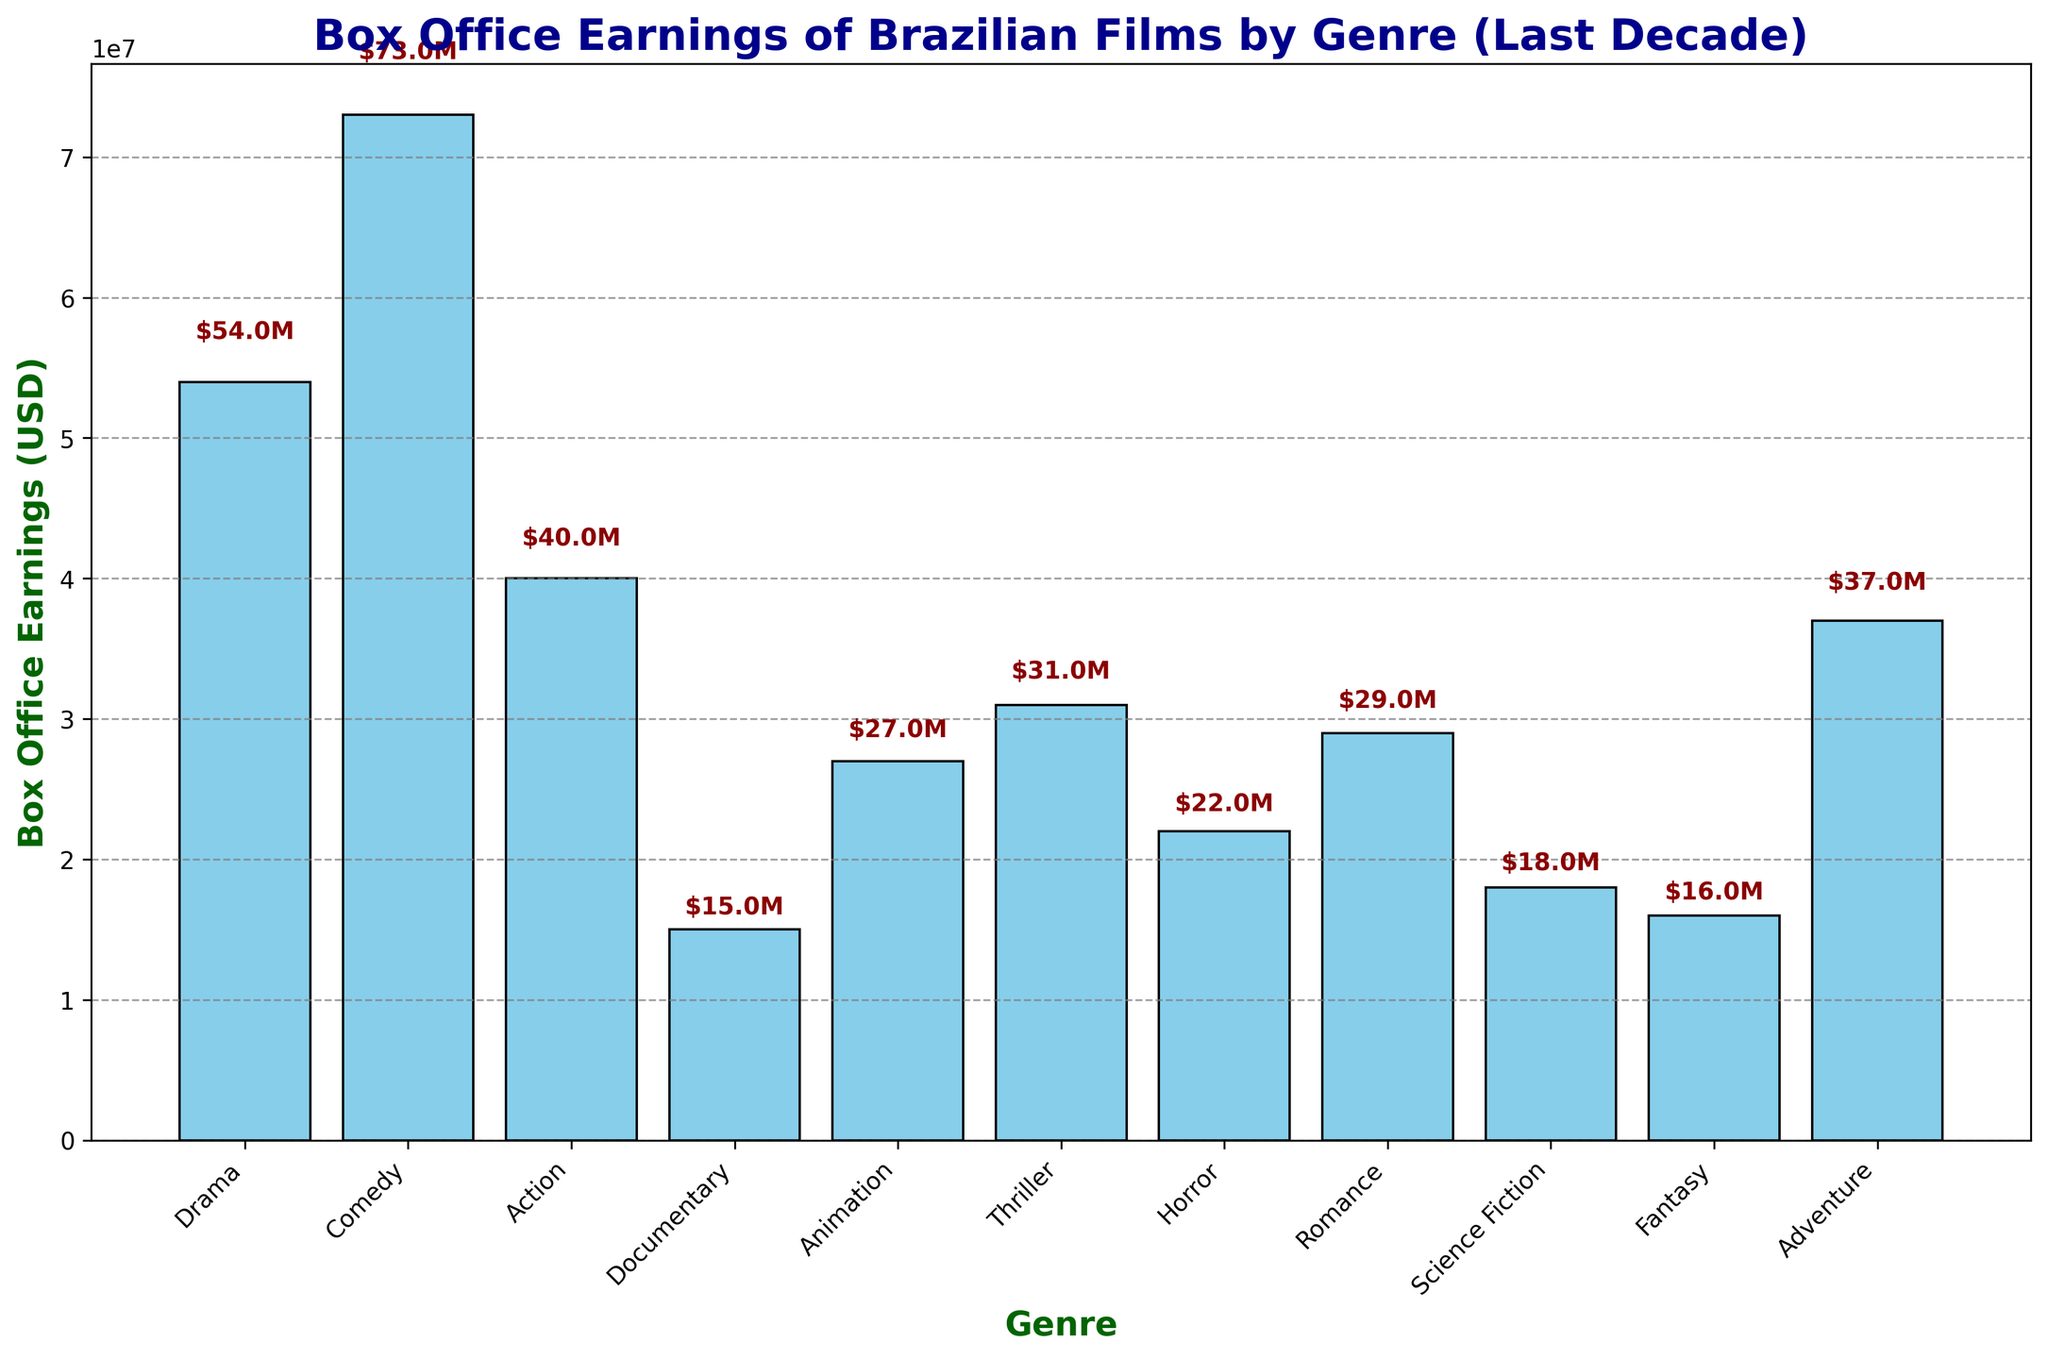Which genre has the highest box office earnings? Look at the heights of the bars on the bar chart. The genre with the tallest bar represents the highest box office earnings.
Answer: Comedy Which genre has the lowest box office earnings? Look at the heights of the bars on the bar chart. The genre with the shortest bar represents the lowest box office earnings.
Answer: Documentary What is the total box office earnings of Drama and Comedy combined? Find the heights of the Drama and Comedy bars and add them together: Drama ($54M) + Comedy ($73M).
Answer: $127M Which genres have box office earnings greater than $30 million? Identify the bars whose heights exceed $30 million. The genres are clearly labeled: Comedy, Drama, Action, Adventure, and Thriller.
Answer: Comedy, Drama, Action, Adventure, Thriller What is the range of box office earnings among all genres? The range is the difference between the highest and lowest values. The highest is $73M (Comedy) and the lowest is $15M (Documentary).
Answer: $58M Which genre has approximately half the box office earnings of Comedy? Half of $73M (Comedy) is about $36.5M. Look for genres whose earnings are close to this value: Adventure with $37M fits.
Answer: Adventure What is the average box office earnings across all genres? Sum all the box office earnings and divide by the number of genres: (54 + 73 + 40 + 15 + 27 + 31 + 22 + 29 + 18 + 16 + 37)M / 11.
Answer: $32.36M Which genre’s box office earnings are closest to the average earnings? Compute the average box office earnings ($32.36M) and find the genre with earnings closest to this value: Thriller ($31M).
Answer: Thriller Which genres have box office earnings more than double that of Documentary? Double the Documentary earnings ($15M) is $30M. Identify genres with earnings higher than $30M: Comedy, Drama, Action, Adventure, Thriller.
Answer: Comedy, Drama, Action, Adventure, Thriller 